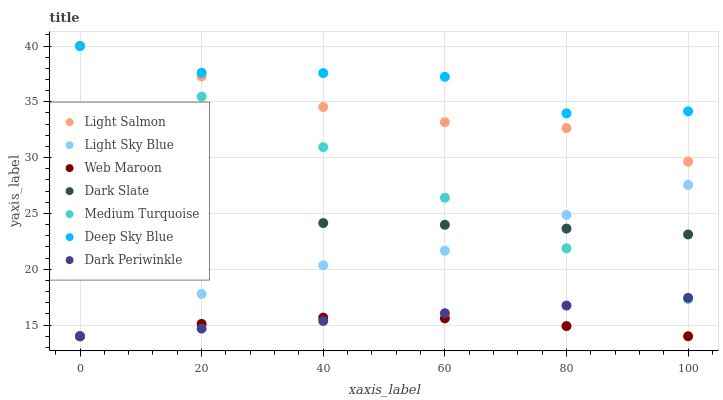Does Web Maroon have the minimum area under the curve?
Answer yes or no. Yes. Does Deep Sky Blue have the maximum area under the curve?
Answer yes or no. Yes. Does Medium Turquoise have the minimum area under the curve?
Answer yes or no. No. Does Medium Turquoise have the maximum area under the curve?
Answer yes or no. No. Is Dark Periwinkle the smoothest?
Answer yes or no. Yes. Is Deep Sky Blue the roughest?
Answer yes or no. Yes. Is Medium Turquoise the smoothest?
Answer yes or no. No. Is Medium Turquoise the roughest?
Answer yes or no. No. Does Web Maroon have the lowest value?
Answer yes or no. Yes. Does Medium Turquoise have the lowest value?
Answer yes or no. No. Does Deep Sky Blue have the highest value?
Answer yes or no. Yes. Does Web Maroon have the highest value?
Answer yes or no. No. Is Web Maroon less than Deep Sky Blue?
Answer yes or no. Yes. Is Dark Slate greater than Dark Periwinkle?
Answer yes or no. Yes. Does Light Sky Blue intersect Dark Slate?
Answer yes or no. Yes. Is Light Sky Blue less than Dark Slate?
Answer yes or no. No. Is Light Sky Blue greater than Dark Slate?
Answer yes or no. No. Does Web Maroon intersect Deep Sky Blue?
Answer yes or no. No. 